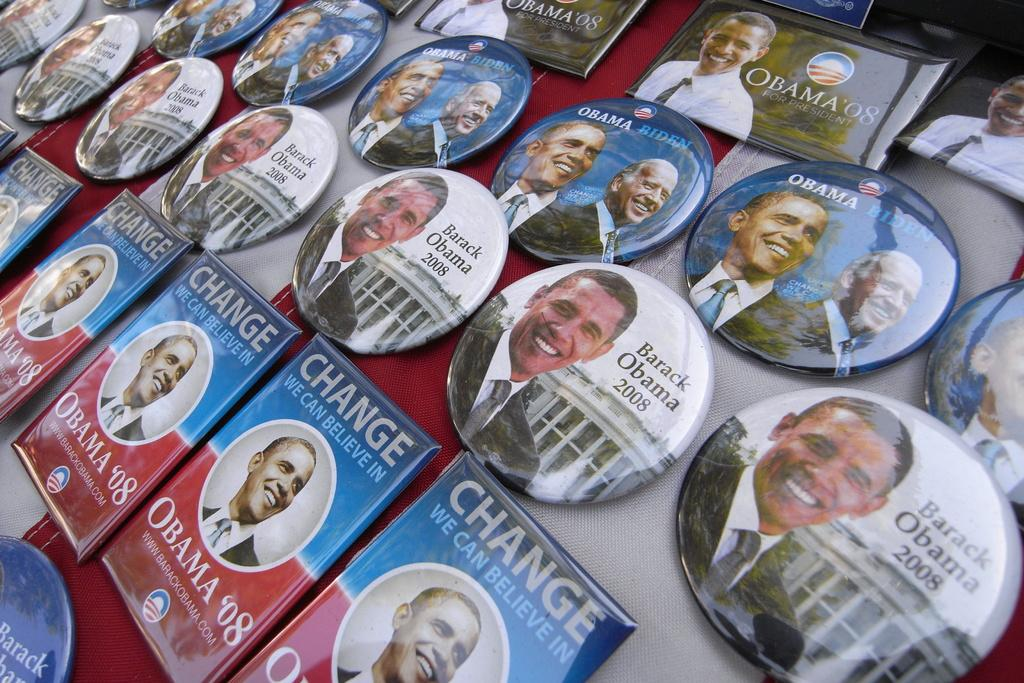What objects are present in the image that have different shapes? There are badges in the image that have different shapes. What can be found on the badges? The badges have something written on them. Who or what can be seen in the image besides the badges? There are persons in the image. What are the dominant colors in the background of the image? The background color of the image is red and white. What type of bird can be seen in the image during the afternoon? There is no bird present in the image, and the time of day is not mentioned. 